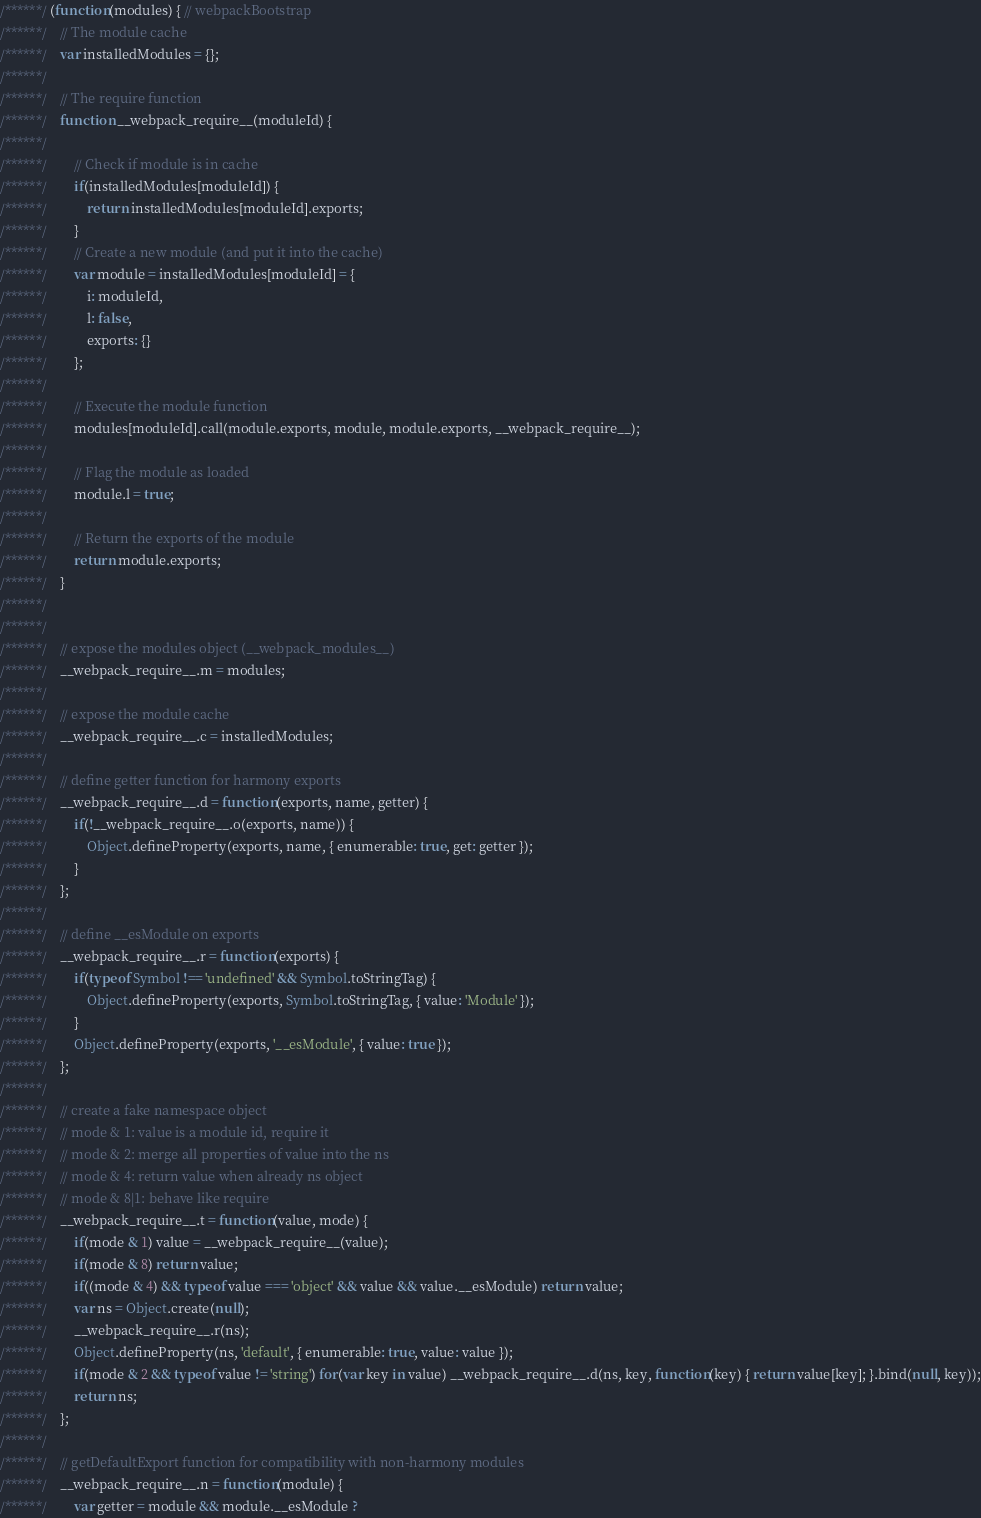Convert code to text. <code><loc_0><loc_0><loc_500><loc_500><_JavaScript_>/******/ (function(modules) { // webpackBootstrap
/******/ 	// The module cache
/******/ 	var installedModules = {};
/******/
/******/ 	// The require function
/******/ 	function __webpack_require__(moduleId) {
/******/
/******/ 		// Check if module is in cache
/******/ 		if(installedModules[moduleId]) {
/******/ 			return installedModules[moduleId].exports;
/******/ 		}
/******/ 		// Create a new module (and put it into the cache)
/******/ 		var module = installedModules[moduleId] = {
/******/ 			i: moduleId,
/******/ 			l: false,
/******/ 			exports: {}
/******/ 		};
/******/
/******/ 		// Execute the module function
/******/ 		modules[moduleId].call(module.exports, module, module.exports, __webpack_require__);
/******/
/******/ 		// Flag the module as loaded
/******/ 		module.l = true;
/******/
/******/ 		// Return the exports of the module
/******/ 		return module.exports;
/******/ 	}
/******/
/******/
/******/ 	// expose the modules object (__webpack_modules__)
/******/ 	__webpack_require__.m = modules;
/******/
/******/ 	// expose the module cache
/******/ 	__webpack_require__.c = installedModules;
/******/
/******/ 	// define getter function for harmony exports
/******/ 	__webpack_require__.d = function(exports, name, getter) {
/******/ 		if(!__webpack_require__.o(exports, name)) {
/******/ 			Object.defineProperty(exports, name, { enumerable: true, get: getter });
/******/ 		}
/******/ 	};
/******/
/******/ 	// define __esModule on exports
/******/ 	__webpack_require__.r = function(exports) {
/******/ 		if(typeof Symbol !== 'undefined' && Symbol.toStringTag) {
/******/ 			Object.defineProperty(exports, Symbol.toStringTag, { value: 'Module' });
/******/ 		}
/******/ 		Object.defineProperty(exports, '__esModule', { value: true });
/******/ 	};
/******/
/******/ 	// create a fake namespace object
/******/ 	// mode & 1: value is a module id, require it
/******/ 	// mode & 2: merge all properties of value into the ns
/******/ 	// mode & 4: return value when already ns object
/******/ 	// mode & 8|1: behave like require
/******/ 	__webpack_require__.t = function(value, mode) {
/******/ 		if(mode & 1) value = __webpack_require__(value);
/******/ 		if(mode & 8) return value;
/******/ 		if((mode & 4) && typeof value === 'object' && value && value.__esModule) return value;
/******/ 		var ns = Object.create(null);
/******/ 		__webpack_require__.r(ns);
/******/ 		Object.defineProperty(ns, 'default', { enumerable: true, value: value });
/******/ 		if(mode & 2 && typeof value != 'string') for(var key in value) __webpack_require__.d(ns, key, function(key) { return value[key]; }.bind(null, key));
/******/ 		return ns;
/******/ 	};
/******/
/******/ 	// getDefaultExport function for compatibility with non-harmony modules
/******/ 	__webpack_require__.n = function(module) {
/******/ 		var getter = module && module.__esModule ?</code> 